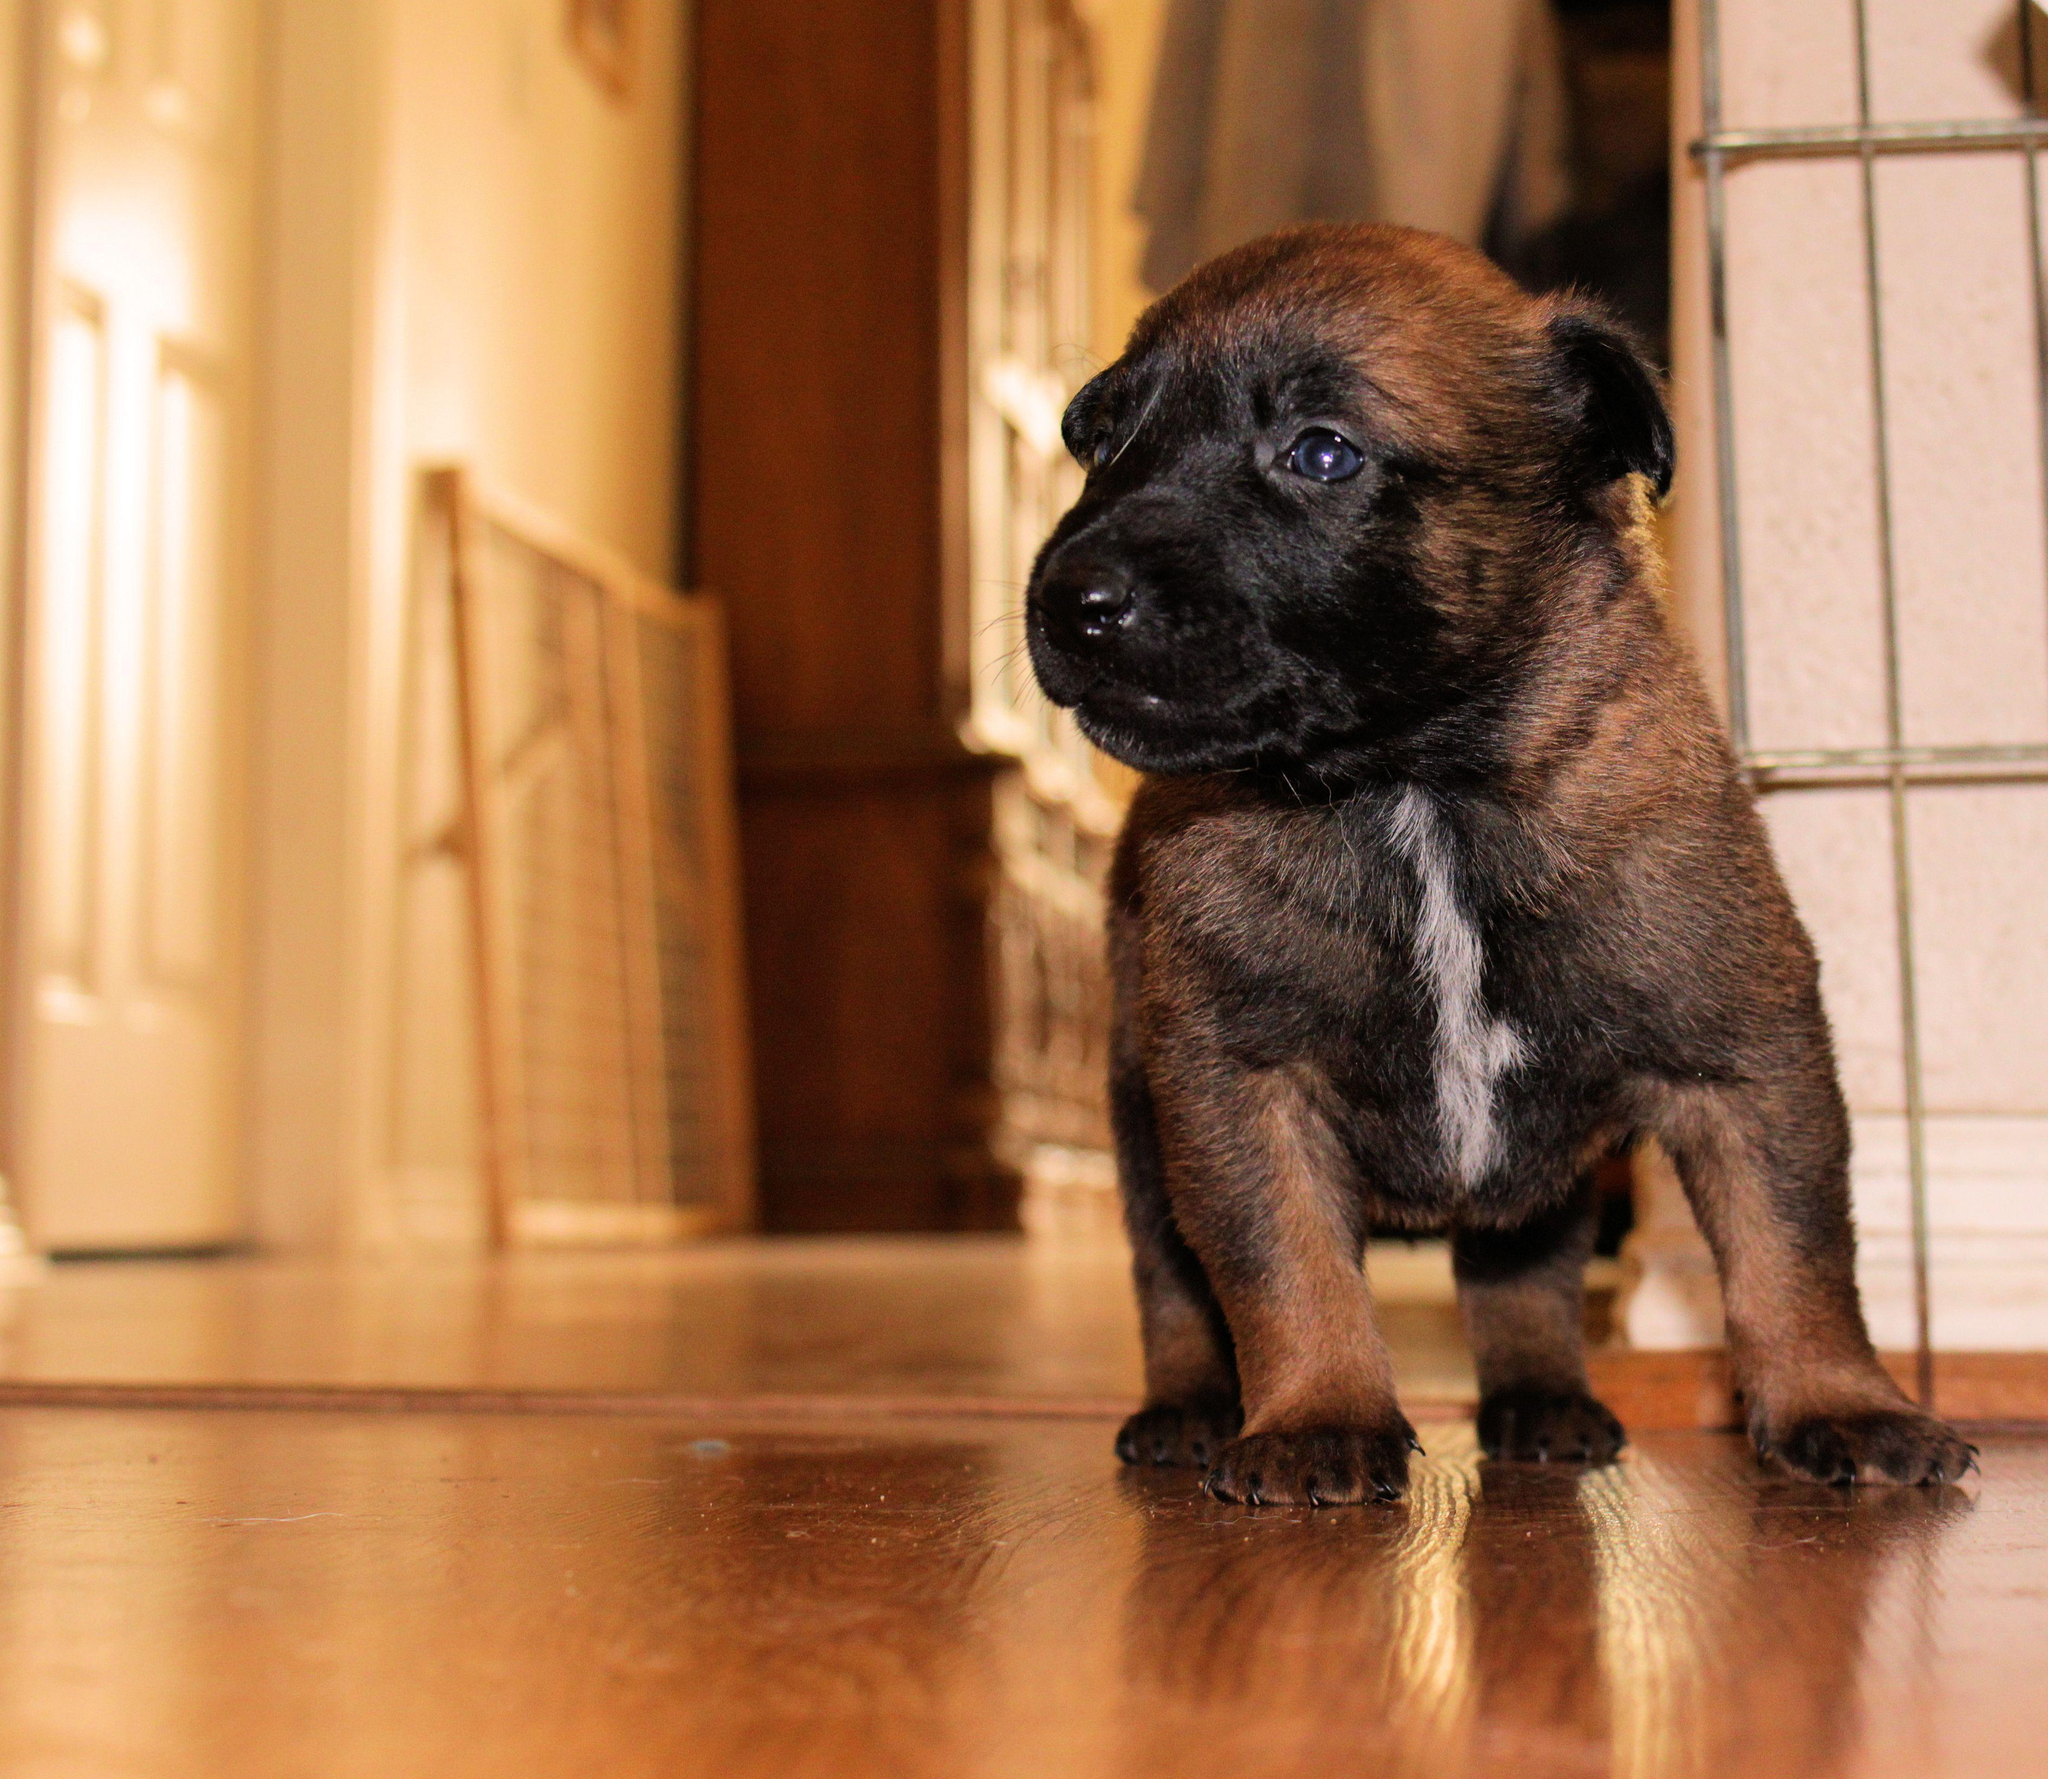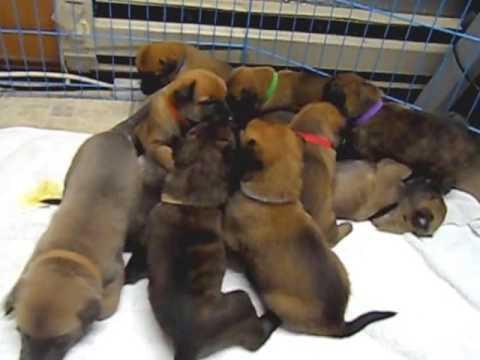The first image is the image on the left, the second image is the image on the right. For the images displayed, is the sentence "A person is holding at least one of the dogs in one of the images." factually correct? Answer yes or no. No. The first image is the image on the left, the second image is the image on the right. Assess this claim about the two images: "A person is holding at least one dog in one image.". Correct or not? Answer yes or no. No. 